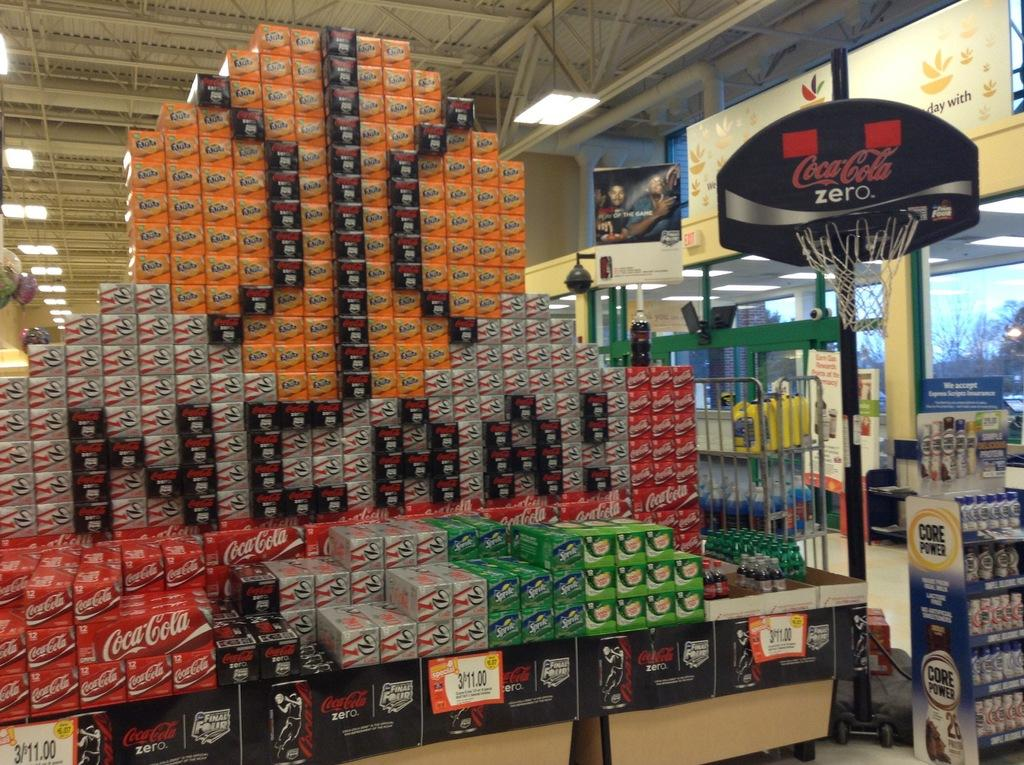<image>
Provide a brief description of the given image. a coke zero basketball net is beside a dispaly at a store 